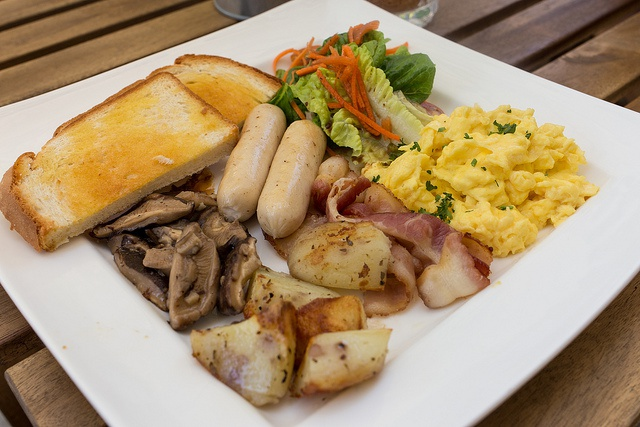Describe the objects in this image and their specific colors. I can see dining table in lightgray, gray, olive, and tan tones, hot dog in maroon, tan, and gray tones, hot dog in maroon, tan, and gray tones, broccoli in maroon, darkgreen, and olive tones, and carrot in maroon, brown, and red tones in this image. 